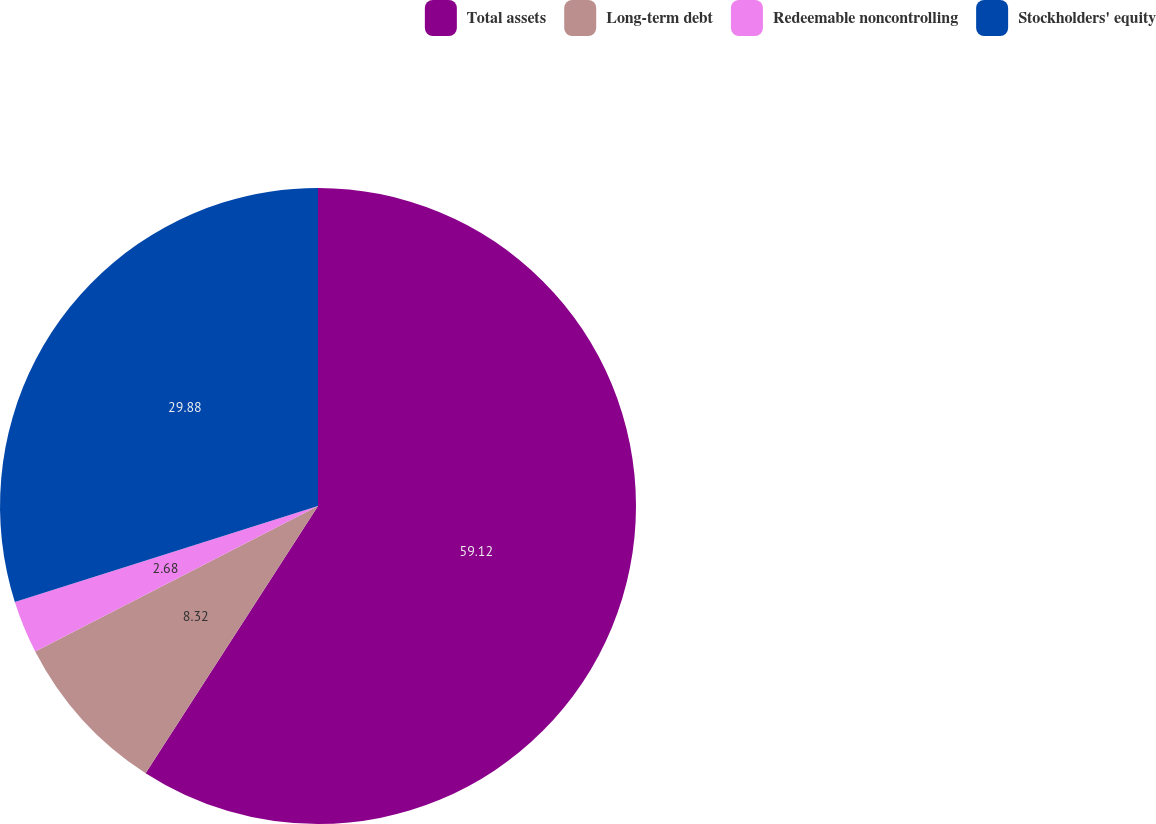Convert chart to OTSL. <chart><loc_0><loc_0><loc_500><loc_500><pie_chart><fcel>Total assets<fcel>Long-term debt<fcel>Redeemable noncontrolling<fcel>Stockholders' equity<nl><fcel>59.12%<fcel>8.32%<fcel>2.68%<fcel>29.88%<nl></chart> 